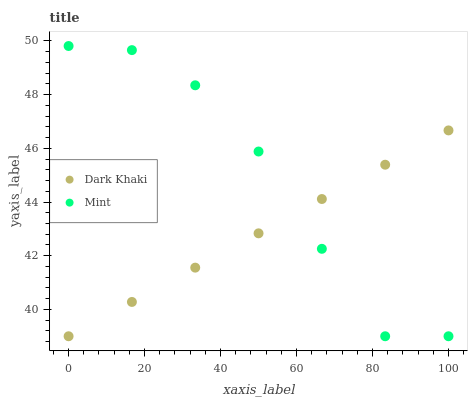Does Dark Khaki have the minimum area under the curve?
Answer yes or no. Yes. Does Mint have the maximum area under the curve?
Answer yes or no. Yes. Does Mint have the minimum area under the curve?
Answer yes or no. No. Is Dark Khaki the smoothest?
Answer yes or no. Yes. Is Mint the roughest?
Answer yes or no. Yes. Is Mint the smoothest?
Answer yes or no. No. Does Dark Khaki have the lowest value?
Answer yes or no. Yes. Does Mint have the highest value?
Answer yes or no. Yes. Does Dark Khaki intersect Mint?
Answer yes or no. Yes. Is Dark Khaki less than Mint?
Answer yes or no. No. Is Dark Khaki greater than Mint?
Answer yes or no. No. 